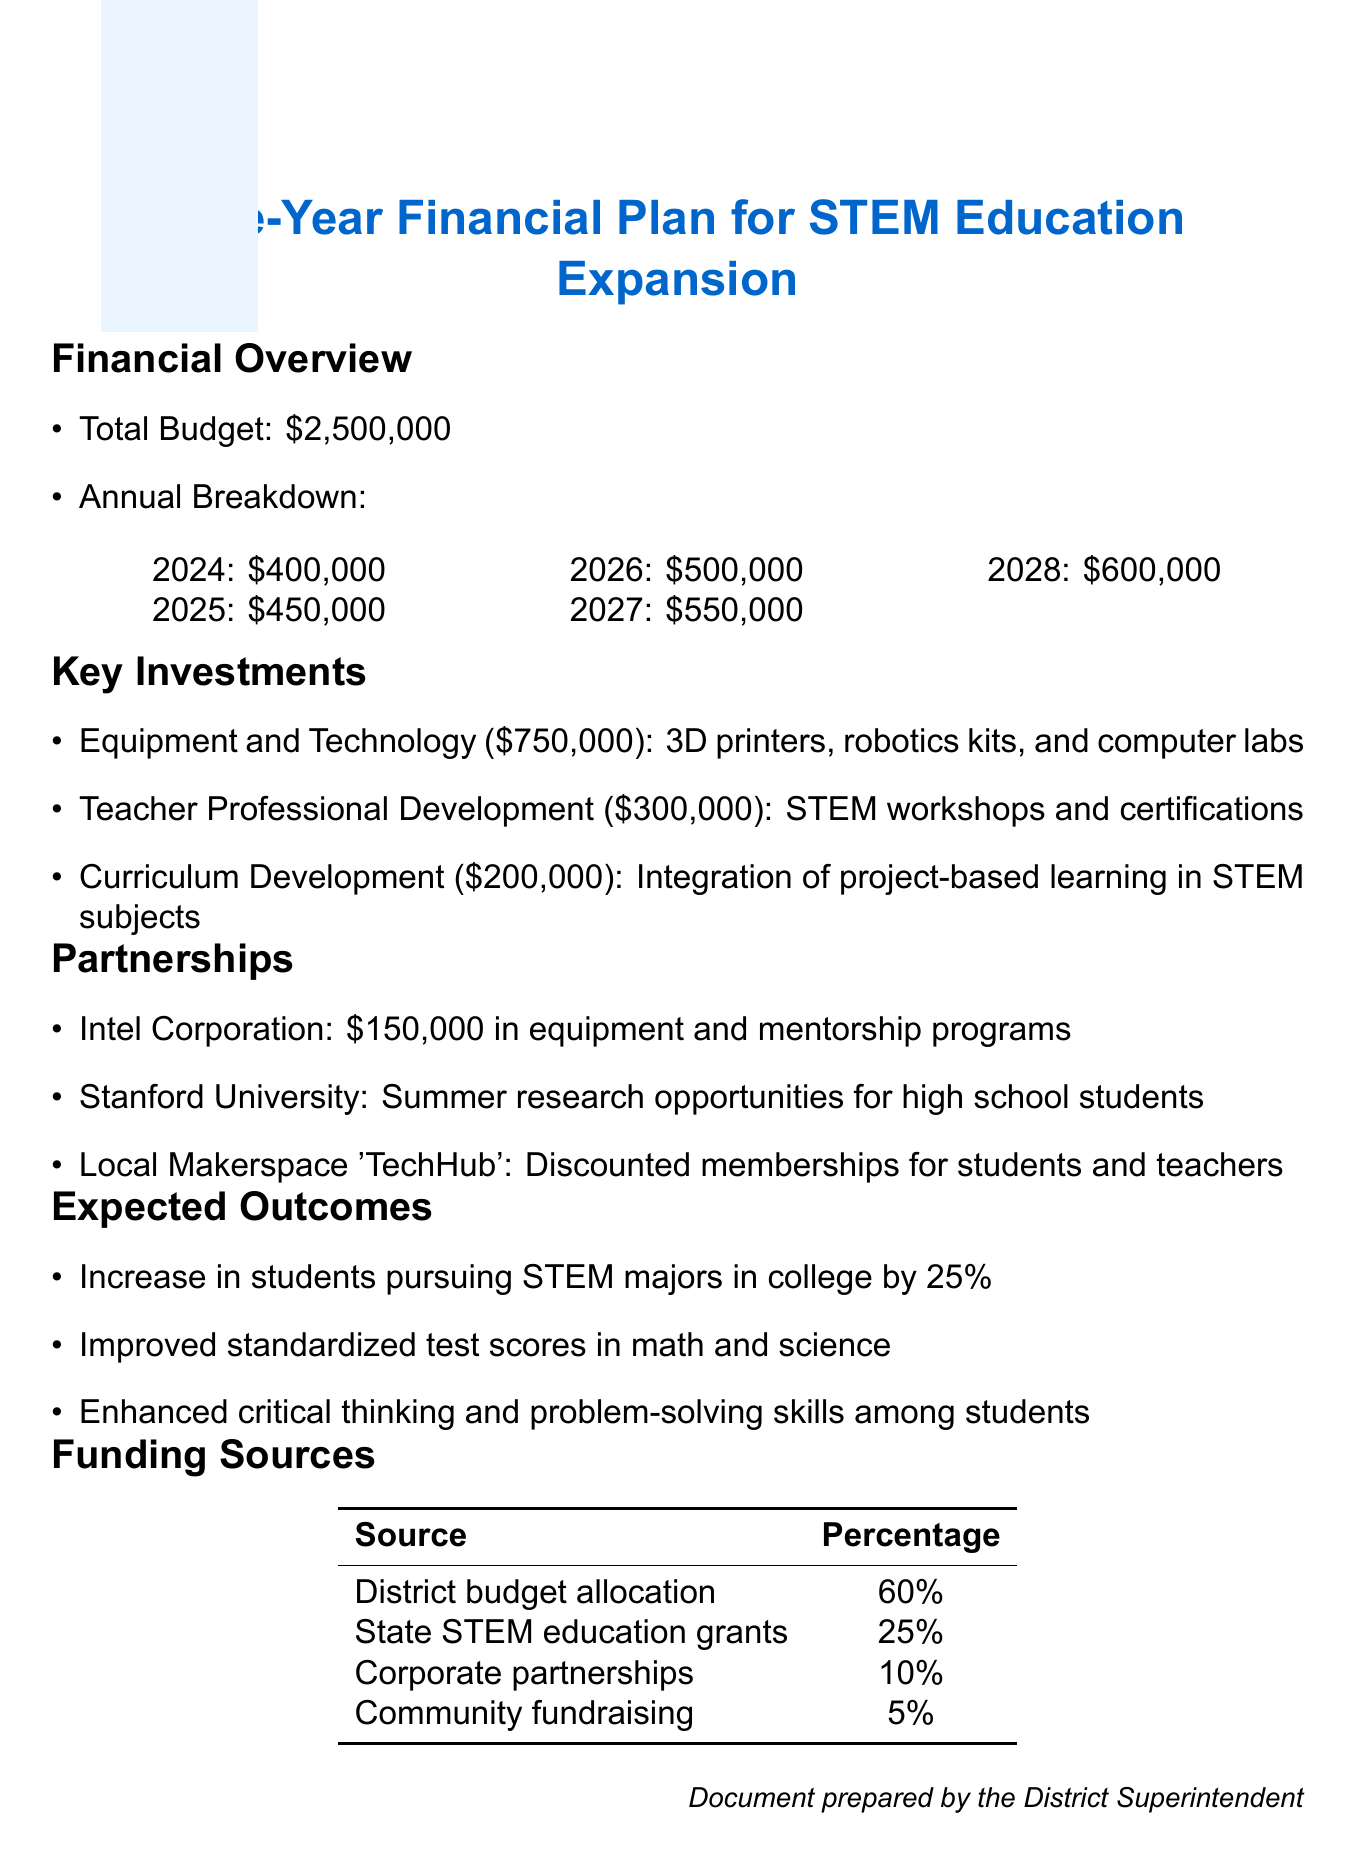What is the total budget for the STEM expansion project? The total budget is stated explicitly in the document as the overall funding amount for the project.
Answer: $2,500,000 How much is allocated for Teacher Professional Development? This information is found under the Key Investments section, detailing the costs associated with teacher training initiatives.
Answer: $300,000 What is the expected percentage increase in students pursuing STEM majors in college? The expected outcome clearly mentions the anticipated growth in students pursuing STEM fields.
Answer: 25% Which company is contributing $150,000 in equipment and mentorship programs? This information is provided in the Partnerships section, specifically naming the contributor.
Answer: Intel Corporation What is the total amount allocated for Equipment and Technology? The Key Investments section lists the costs for various categories, including Equipment and Technology.
Answer: $750,000 What percentage of the funding comes from the District budget allocation? The document provides this specific percentage in the Funding Sources section.
Answer: 60% How much funding is allocated in 2026? This figure is provided in the annual budget breakdown section and highlights the allocated amount for that year.
Answer: $500,000 What type of opportunities does Stanford University provide as a partnership? The document describes specific contributions from each partner, highlighting the type of opportunities offered.
Answer: Summer research opportunities for high school students 